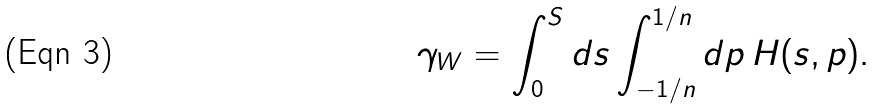<formula> <loc_0><loc_0><loc_500><loc_500>\gamma _ { W } = \int _ { 0 } ^ { S } d s \int _ { - 1 / n } ^ { 1 / n } d p \, H ( s , p ) .</formula> 